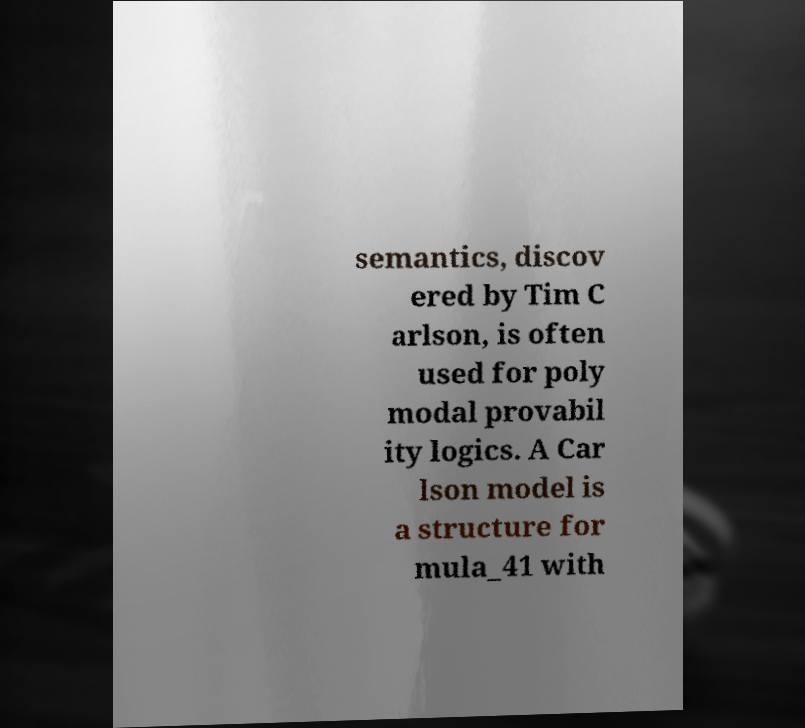Please identify and transcribe the text found in this image. semantics, discov ered by Tim C arlson, is often used for poly modal provabil ity logics. A Car lson model is a structure for mula_41 with 